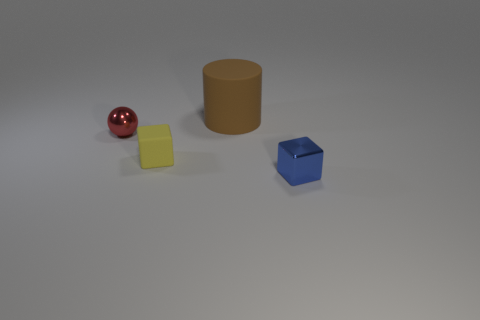Add 1 blue things. How many objects exist? 5 Subtract all cylinders. How many objects are left? 3 Add 1 tiny green metal cubes. How many tiny green metal cubes exist? 1 Subtract 0 red cubes. How many objects are left? 4 Subtract all gray matte spheres. Subtract all tiny blue cubes. How many objects are left? 3 Add 1 small blue cubes. How many small blue cubes are left? 2 